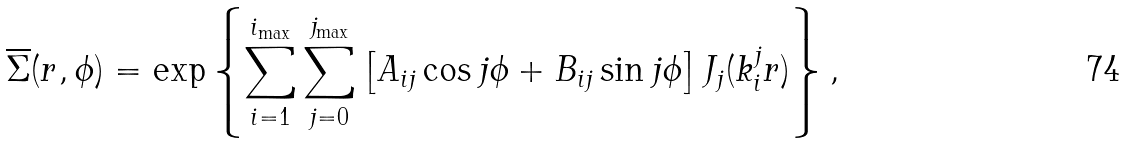<formula> <loc_0><loc_0><loc_500><loc_500>\overline { \Sigma } ( r , \phi ) = \exp \left \{ \sum _ { i = 1 } ^ { i _ { \max } } \sum _ { j = 0 } ^ { j _ { \max } } \left [ A _ { i j } \cos j \phi + B _ { i j } \sin j \phi \right ] J _ { j } ( k _ { i } ^ { j } r ) \right \} ,</formula> 